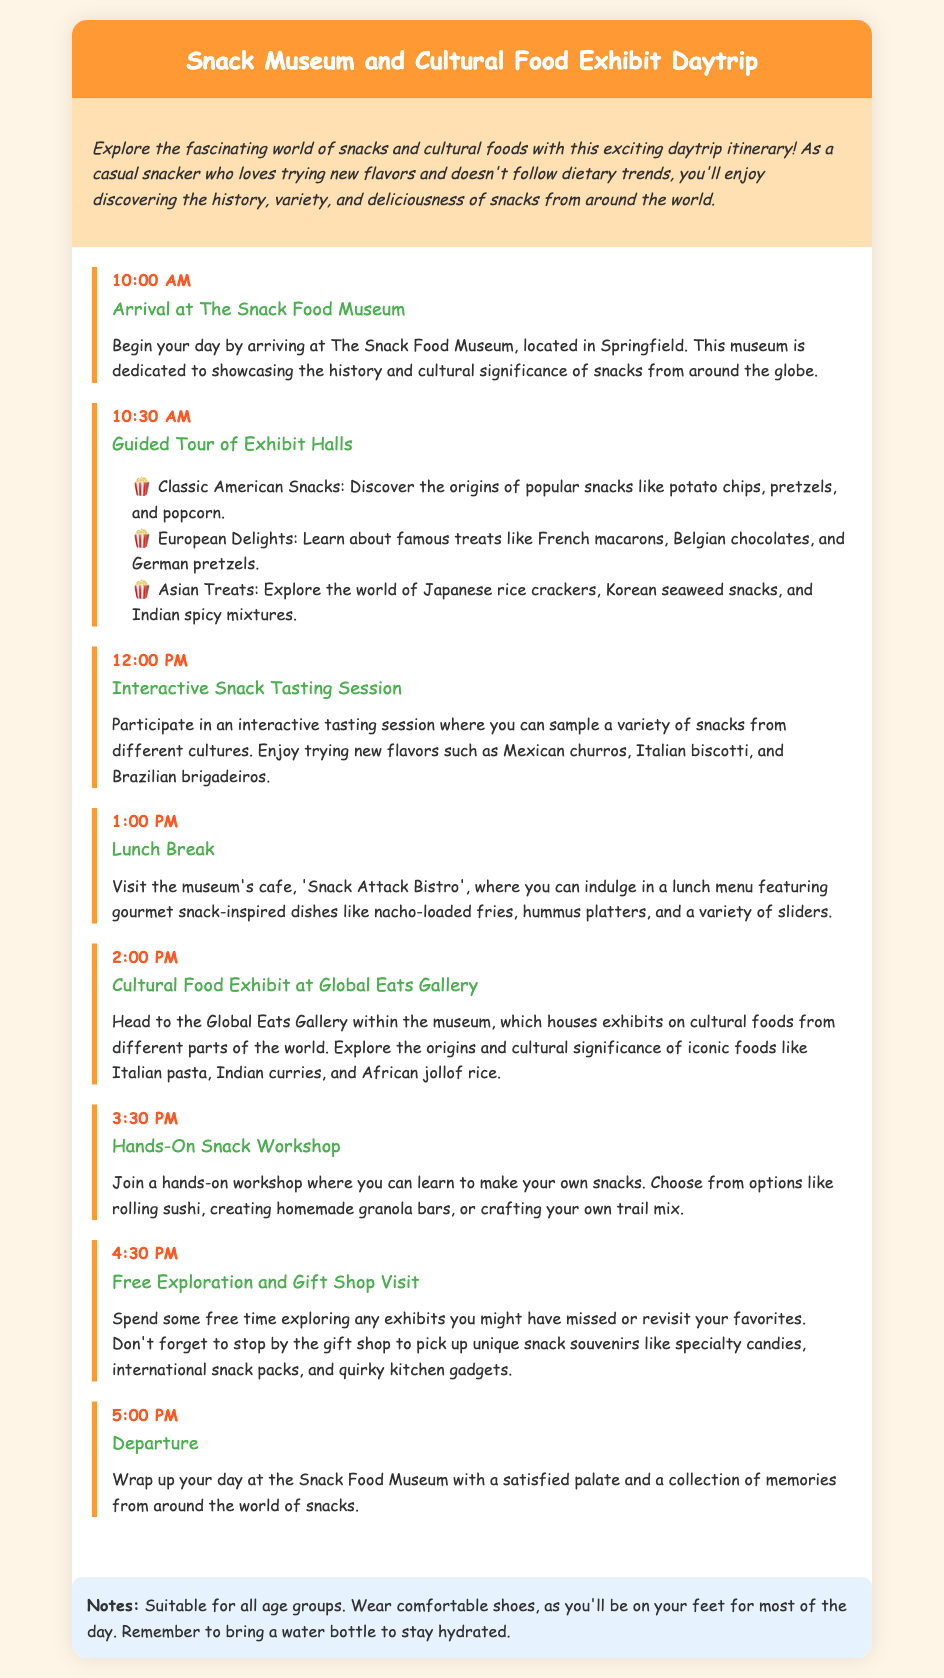What time does the daytrip start? The daytrip starts at 10:00 AM as listed in the itinerary.
Answer: 10:00 AM Where is The Snack Food Museum located? The location of The Snack Food Museum is mentioned as Springfield in the document.
Answer: Springfield What type of snacks will be sampled during the interactive tasting session? The interactive tasting session includes various snacks such as Mexican churros, Italian biscotti, and Brazilian brigadeiros.
Answer: Mexican churros, Italian biscotti, Brazilian brigadeiros What is the name of the cafe at the museum? The cafe’s name is ‘Snack Attack Bistro’ as stated in the lunch break details.
Answer: Snack Attack Bistro What activity follows the lunch break? The activity that follows lunch is the Cultural Food Exhibit at Global Eats Gallery in the itinerary.
Answer: Cultural Food Exhibit at Global Eats Gallery How long is the guided tour of the exhibit halls? The guided tour occurs from 10:30 AM to 12:00 PM, which totals 1 hour and 30 minutes.
Answer: 1 hour and 30 minutes What workshop can attendees join in the afternoon? Attendees can join a hands-on snack workshop, which allows them to learn to make their own snacks.
Answer: Hands-on snack workshop What is recommended to bring for the trip? It is recommended to bring a water bottle to stay hydrated as noted in the notes section.
Answer: Water bottle 